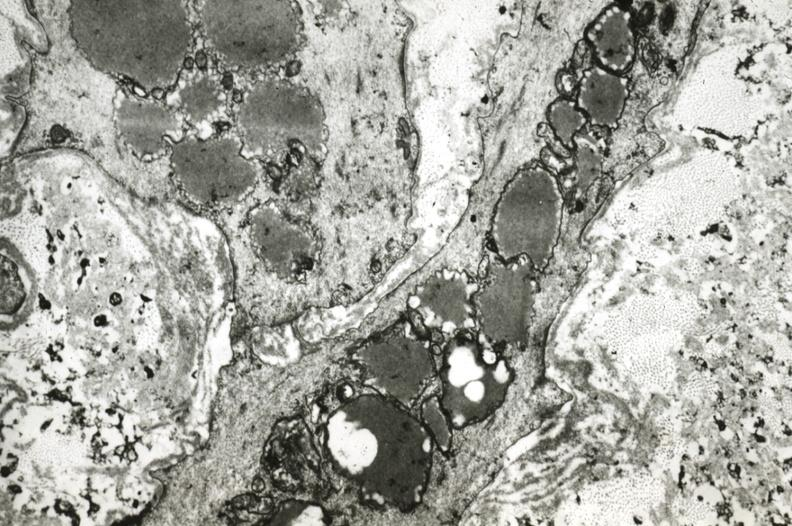what is present?
Answer the question using a single word or phrase. Coronary artery 